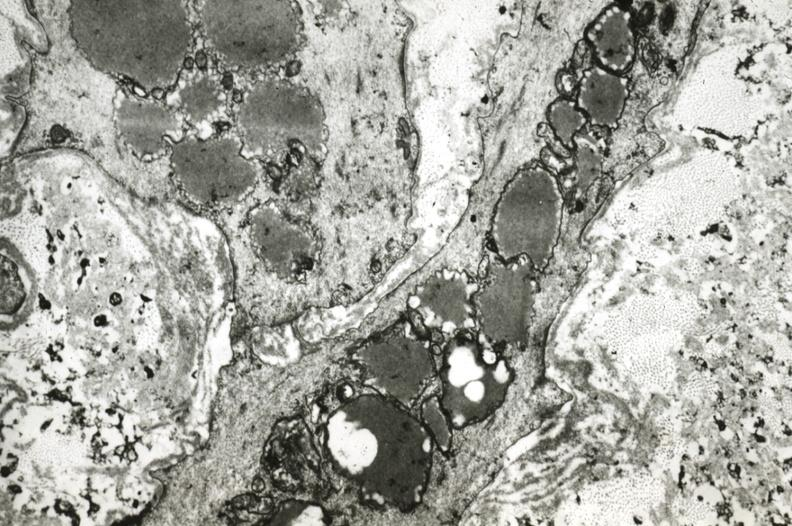what is present?
Answer the question using a single word or phrase. Coronary artery 